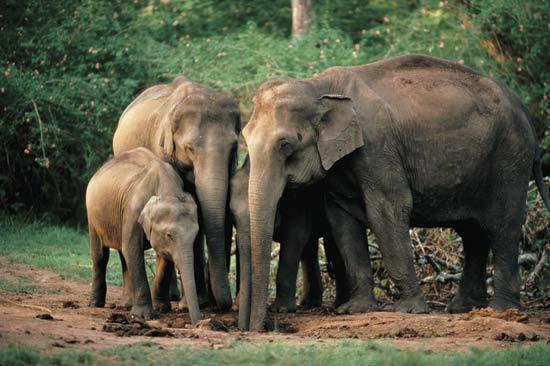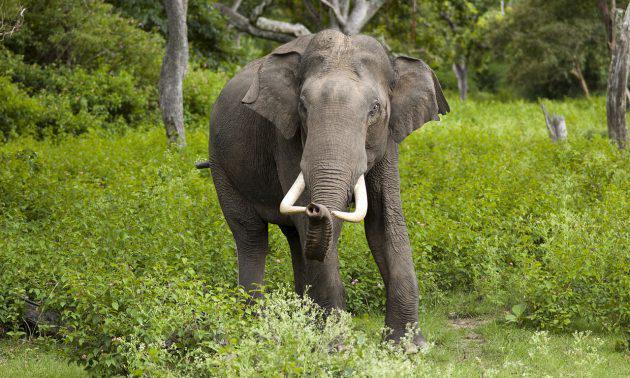The first image is the image on the left, the second image is the image on the right. Assess this claim about the two images: "The left image shows one lone adult elephant, while the right image shows one adult elephant with one younger elephant beside it". Correct or not? Answer yes or no. No. The first image is the image on the left, the second image is the image on the right. Analyze the images presented: Is the assertion "There is exactly two elephants in the right image." valid? Answer yes or no. No. 